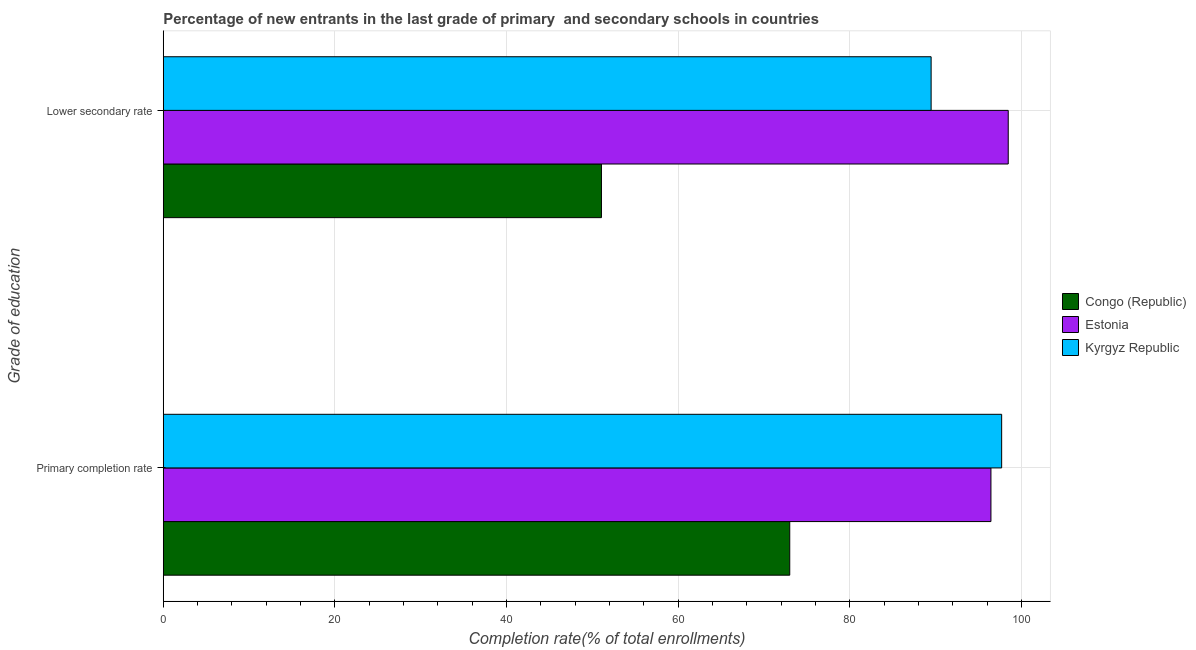How many different coloured bars are there?
Your answer should be very brief. 3. Are the number of bars per tick equal to the number of legend labels?
Your response must be concise. Yes. How many bars are there on the 1st tick from the top?
Make the answer very short. 3. How many bars are there on the 2nd tick from the bottom?
Make the answer very short. 3. What is the label of the 2nd group of bars from the top?
Make the answer very short. Primary completion rate. What is the completion rate in primary schools in Congo (Republic)?
Give a very brief answer. 72.98. Across all countries, what is the maximum completion rate in primary schools?
Give a very brief answer. 97.67. Across all countries, what is the minimum completion rate in primary schools?
Provide a short and direct response. 72.98. In which country was the completion rate in primary schools maximum?
Make the answer very short. Kyrgyz Republic. In which country was the completion rate in primary schools minimum?
Offer a very short reply. Congo (Republic). What is the total completion rate in primary schools in the graph?
Provide a short and direct response. 267.07. What is the difference between the completion rate in primary schools in Congo (Republic) and that in Kyrgyz Republic?
Provide a short and direct response. -24.69. What is the difference between the completion rate in secondary schools in Estonia and the completion rate in primary schools in Congo (Republic)?
Provide a succinct answer. 25.45. What is the average completion rate in primary schools per country?
Keep it short and to the point. 89.02. What is the difference between the completion rate in secondary schools and completion rate in primary schools in Estonia?
Provide a succinct answer. 2.01. What is the ratio of the completion rate in primary schools in Estonia to that in Congo (Republic)?
Give a very brief answer. 1.32. What does the 3rd bar from the top in Lower secondary rate represents?
Offer a terse response. Congo (Republic). What does the 3rd bar from the bottom in Lower secondary rate represents?
Make the answer very short. Kyrgyz Republic. How many bars are there?
Ensure brevity in your answer.  6. Are the values on the major ticks of X-axis written in scientific E-notation?
Ensure brevity in your answer.  No. How are the legend labels stacked?
Offer a terse response. Vertical. What is the title of the graph?
Offer a terse response. Percentage of new entrants in the last grade of primary  and secondary schools in countries. What is the label or title of the X-axis?
Your answer should be compact. Completion rate(% of total enrollments). What is the label or title of the Y-axis?
Your answer should be compact. Grade of education. What is the Completion rate(% of total enrollments) of Congo (Republic) in Primary completion rate?
Offer a very short reply. 72.98. What is the Completion rate(% of total enrollments) in Estonia in Primary completion rate?
Offer a very short reply. 96.42. What is the Completion rate(% of total enrollments) of Kyrgyz Republic in Primary completion rate?
Your answer should be compact. 97.67. What is the Completion rate(% of total enrollments) of Congo (Republic) in Lower secondary rate?
Keep it short and to the point. 51.05. What is the Completion rate(% of total enrollments) in Estonia in Lower secondary rate?
Your response must be concise. 98.43. What is the Completion rate(% of total enrollments) in Kyrgyz Republic in Lower secondary rate?
Ensure brevity in your answer.  89.45. Across all Grade of education, what is the maximum Completion rate(% of total enrollments) in Congo (Republic)?
Your answer should be compact. 72.98. Across all Grade of education, what is the maximum Completion rate(% of total enrollments) of Estonia?
Make the answer very short. 98.43. Across all Grade of education, what is the maximum Completion rate(% of total enrollments) of Kyrgyz Republic?
Keep it short and to the point. 97.67. Across all Grade of education, what is the minimum Completion rate(% of total enrollments) of Congo (Republic)?
Offer a very short reply. 51.05. Across all Grade of education, what is the minimum Completion rate(% of total enrollments) in Estonia?
Offer a very short reply. 96.42. Across all Grade of education, what is the minimum Completion rate(% of total enrollments) of Kyrgyz Republic?
Provide a short and direct response. 89.45. What is the total Completion rate(% of total enrollments) of Congo (Republic) in the graph?
Provide a succinct answer. 124.03. What is the total Completion rate(% of total enrollments) in Estonia in the graph?
Your response must be concise. 194.86. What is the total Completion rate(% of total enrollments) of Kyrgyz Republic in the graph?
Offer a very short reply. 187.12. What is the difference between the Completion rate(% of total enrollments) in Congo (Republic) in Primary completion rate and that in Lower secondary rate?
Ensure brevity in your answer.  21.94. What is the difference between the Completion rate(% of total enrollments) in Estonia in Primary completion rate and that in Lower secondary rate?
Your answer should be compact. -2.01. What is the difference between the Completion rate(% of total enrollments) of Kyrgyz Republic in Primary completion rate and that in Lower secondary rate?
Provide a succinct answer. 8.22. What is the difference between the Completion rate(% of total enrollments) of Congo (Republic) in Primary completion rate and the Completion rate(% of total enrollments) of Estonia in Lower secondary rate?
Offer a terse response. -25.45. What is the difference between the Completion rate(% of total enrollments) of Congo (Republic) in Primary completion rate and the Completion rate(% of total enrollments) of Kyrgyz Republic in Lower secondary rate?
Your answer should be very brief. -16.47. What is the difference between the Completion rate(% of total enrollments) of Estonia in Primary completion rate and the Completion rate(% of total enrollments) of Kyrgyz Republic in Lower secondary rate?
Your answer should be compact. 6.97. What is the average Completion rate(% of total enrollments) in Congo (Republic) per Grade of education?
Give a very brief answer. 62.01. What is the average Completion rate(% of total enrollments) of Estonia per Grade of education?
Your response must be concise. 97.43. What is the average Completion rate(% of total enrollments) of Kyrgyz Republic per Grade of education?
Provide a succinct answer. 93.56. What is the difference between the Completion rate(% of total enrollments) in Congo (Republic) and Completion rate(% of total enrollments) in Estonia in Primary completion rate?
Offer a terse response. -23.44. What is the difference between the Completion rate(% of total enrollments) in Congo (Republic) and Completion rate(% of total enrollments) in Kyrgyz Republic in Primary completion rate?
Your response must be concise. -24.69. What is the difference between the Completion rate(% of total enrollments) in Estonia and Completion rate(% of total enrollments) in Kyrgyz Republic in Primary completion rate?
Offer a very short reply. -1.25. What is the difference between the Completion rate(% of total enrollments) of Congo (Republic) and Completion rate(% of total enrollments) of Estonia in Lower secondary rate?
Make the answer very short. -47.39. What is the difference between the Completion rate(% of total enrollments) of Congo (Republic) and Completion rate(% of total enrollments) of Kyrgyz Republic in Lower secondary rate?
Give a very brief answer. -38.41. What is the difference between the Completion rate(% of total enrollments) of Estonia and Completion rate(% of total enrollments) of Kyrgyz Republic in Lower secondary rate?
Your response must be concise. 8.98. What is the ratio of the Completion rate(% of total enrollments) of Congo (Republic) in Primary completion rate to that in Lower secondary rate?
Your answer should be compact. 1.43. What is the ratio of the Completion rate(% of total enrollments) of Estonia in Primary completion rate to that in Lower secondary rate?
Ensure brevity in your answer.  0.98. What is the ratio of the Completion rate(% of total enrollments) of Kyrgyz Republic in Primary completion rate to that in Lower secondary rate?
Your response must be concise. 1.09. What is the difference between the highest and the second highest Completion rate(% of total enrollments) in Congo (Republic)?
Your response must be concise. 21.94. What is the difference between the highest and the second highest Completion rate(% of total enrollments) of Estonia?
Give a very brief answer. 2.01. What is the difference between the highest and the second highest Completion rate(% of total enrollments) of Kyrgyz Republic?
Keep it short and to the point. 8.22. What is the difference between the highest and the lowest Completion rate(% of total enrollments) of Congo (Republic)?
Your answer should be very brief. 21.94. What is the difference between the highest and the lowest Completion rate(% of total enrollments) of Estonia?
Offer a very short reply. 2.01. What is the difference between the highest and the lowest Completion rate(% of total enrollments) in Kyrgyz Republic?
Keep it short and to the point. 8.22. 